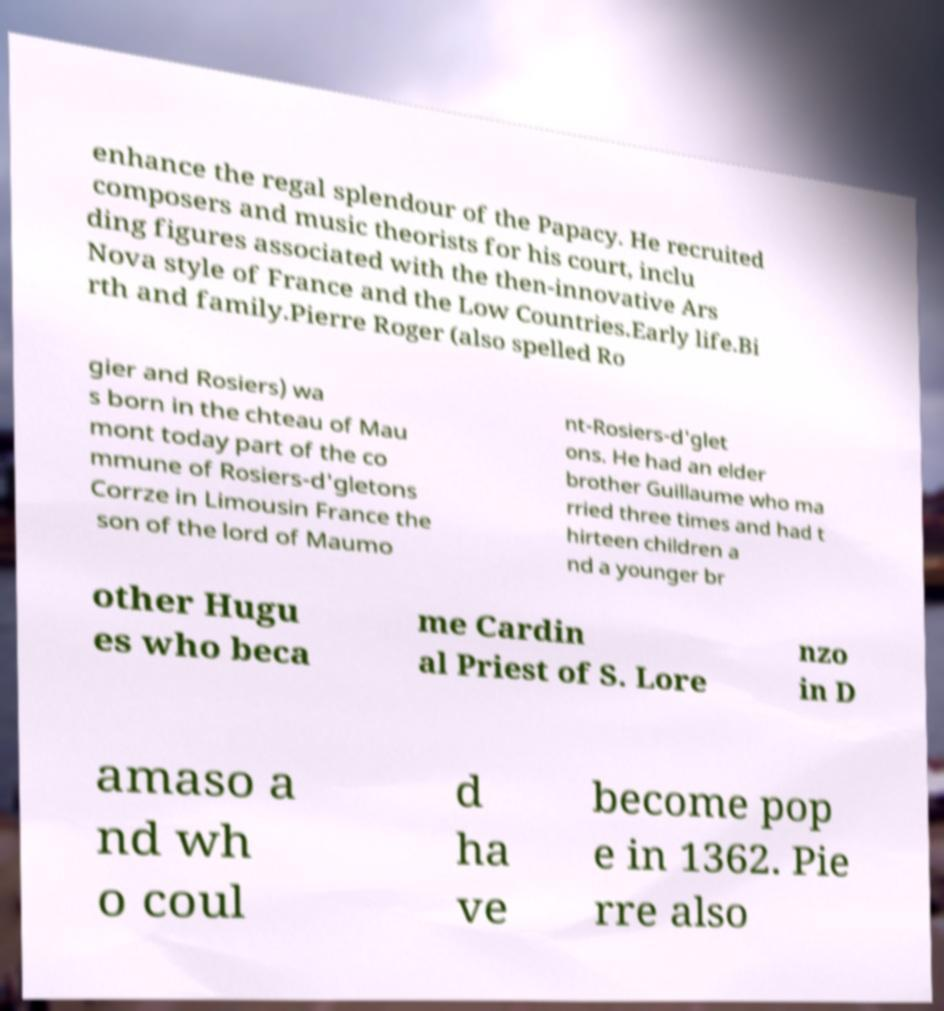Could you extract and type out the text from this image? enhance the regal splendour of the Papacy. He recruited composers and music theorists for his court, inclu ding figures associated with the then-innovative Ars Nova style of France and the Low Countries.Early life.Bi rth and family.Pierre Roger (also spelled Ro gier and Rosiers) wa s born in the chteau of Mau mont today part of the co mmune of Rosiers-d'gletons Corrze in Limousin France the son of the lord of Maumo nt-Rosiers-d'glet ons. He had an elder brother Guillaume who ma rried three times and had t hirteen children a nd a younger br other Hugu es who beca me Cardin al Priest of S. Lore nzo in D amaso a nd wh o coul d ha ve become pop e in 1362. Pie rre also 